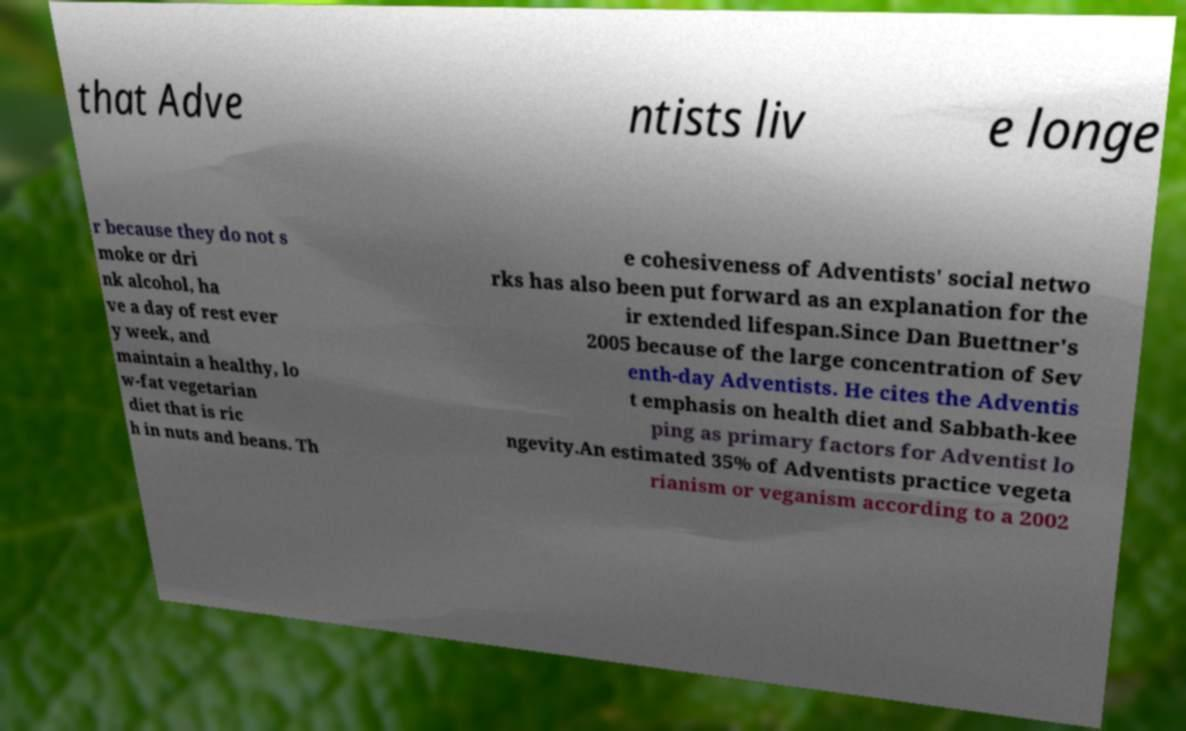Could you assist in decoding the text presented in this image and type it out clearly? that Adve ntists liv e longe r because they do not s moke or dri nk alcohol, ha ve a day of rest ever y week, and maintain a healthy, lo w-fat vegetarian diet that is ric h in nuts and beans. Th e cohesiveness of Adventists' social netwo rks has also been put forward as an explanation for the ir extended lifespan.Since Dan Buettner's 2005 because of the large concentration of Sev enth-day Adventists. He cites the Adventis t emphasis on health diet and Sabbath-kee ping as primary factors for Adventist lo ngevity.An estimated 35% of Adventists practice vegeta rianism or veganism according to a 2002 